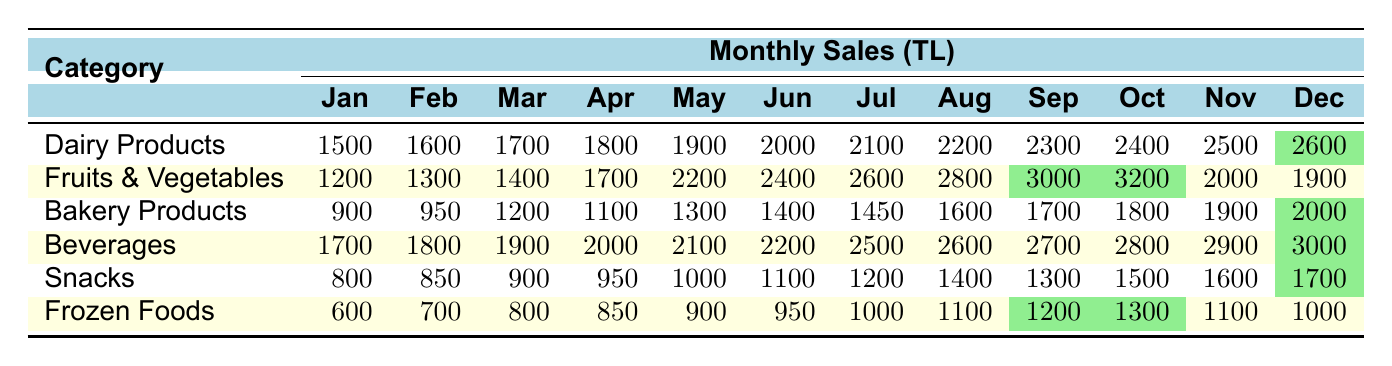What was the highest sales month for Dairy Products? The table shows that December has the highest sales for Dairy Products with a total of 2600 TL.
Answer: 2600 TL Which product category had the lowest sales in January? In January, the sales for Frozen Foods were the lowest at 600 TL compared to all other categories.
Answer: 600 TL What is the total sales for Fruits & Vegetables from January to June? The sales from January (1200) to June (2400) for Fruits & Vegetables can be summed up as 1200 + 1300 + 1400 + 1700 + 2200 + 2400 = 11200 TL.
Answer: 11200 TL In which month did Beverages have the highest sales, and what was the amount? The highest sales for Beverages occurred in December with a total of 3000 TL.
Answer: 3000 TL Did Snacks sales increase every month? The sales for Snacks do not increase every month; for example, in September, sales were 1300 TL, but in October, sales increased to 1500 TL, and then in November, it increased again to 1600 TL.
Answer: No What is the average sales for Bakery Products over the year? The total sales for Bakery Products from January to December is 900 + 950 + 1200 + 1100 + 1300 + 1400 + 1450 + 1600 + 1700 + 1800 + 1900 + 2000 = 17900 TL. The average is 17900 / 12 = 1491.67 TL.
Answer: 1491.67 TL Which product category had the most significant sales increase in May compared to April? The increase for Fruits & Vegetables from April (1700) to May (2200) is 2200 - 1700 = 500 TL, while for Dairy Products, the increase is 1900 - 1800 = 100 TL. Fruits & Vegetables had a higher increase.
Answer: Fruits & Vegetables What was the sales trend for Frozen Foods from January to December? The sales for Frozen Foods started at 600 TL in January and peaked at 1300 TL in October, then dropped to 1100 TL in November and 1000 TL in December, indicating an overall increase until October, followed by a decline.
Answer: Increase until October, then decline Was the total sales for Snacks lower than that for Dairy Products in any month? Yes, in January, Snacks had sales of 800 TL compared to Dairy Products which had 1500 TL.
Answer: Yes What catgory had the smallest amount of sales in April? In April, Frozen Foods had the smallest amount of sales at 850 TL compared to other categories.
Answer: 850 TL 